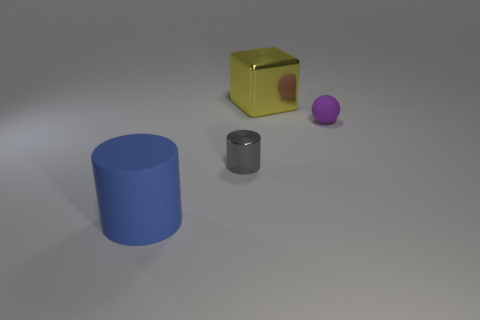There is a purple thing that is the same size as the gray cylinder; what shape is it?
Provide a short and direct response. Sphere. Do the small shiny object and the small purple matte object have the same shape?
Offer a terse response. No. What number of small shiny things have the same shape as the blue matte thing?
Provide a short and direct response. 1. There is a shiny block; how many big objects are in front of it?
Provide a succinct answer. 1. Is the color of the cylinder left of the small metallic cylinder the same as the big block?
Give a very brief answer. No. What number of matte spheres are the same size as the block?
Keep it short and to the point. 0. What shape is the other object that is made of the same material as the purple thing?
Keep it short and to the point. Cylinder. Is there a big cylinder that has the same color as the big cube?
Offer a very short reply. No. What material is the gray cylinder?
Provide a succinct answer. Metal. How many objects are either big metallic objects or gray shiny objects?
Give a very brief answer. 2. 